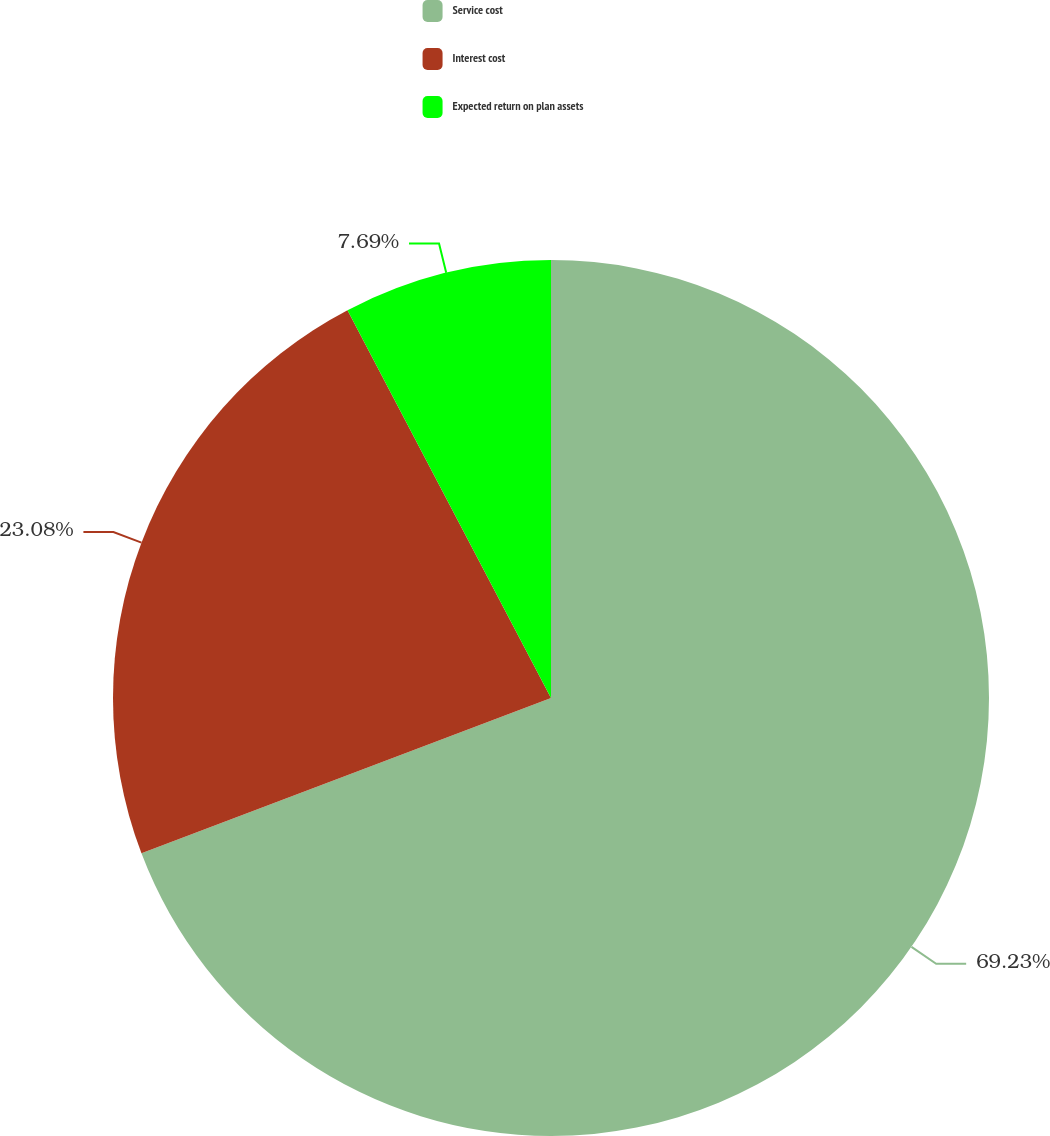Convert chart to OTSL. <chart><loc_0><loc_0><loc_500><loc_500><pie_chart><fcel>Service cost<fcel>Interest cost<fcel>Expected return on plan assets<nl><fcel>69.23%<fcel>23.08%<fcel>7.69%<nl></chart> 